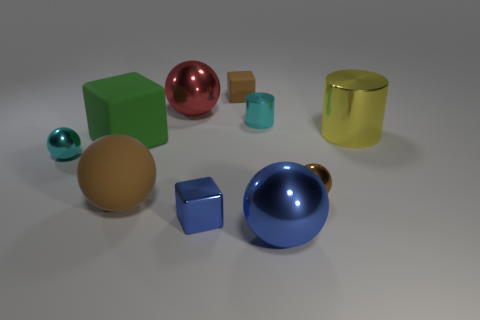How many things are brown rubber balls that are in front of the big green matte object or spheres that are right of the green object? There are a total of two brown objects in the image. However, none of them is a rubber ball in front of the big green matte object as there are no brown balls in the foreground relative to the green cube. Two brown objects can be observed - one sphere and one cube - but they are positioned in the center and left of the green matte object rather than to the right. It's important to note that objects' materials are not clearly indicative of being rubber in the provided image. 